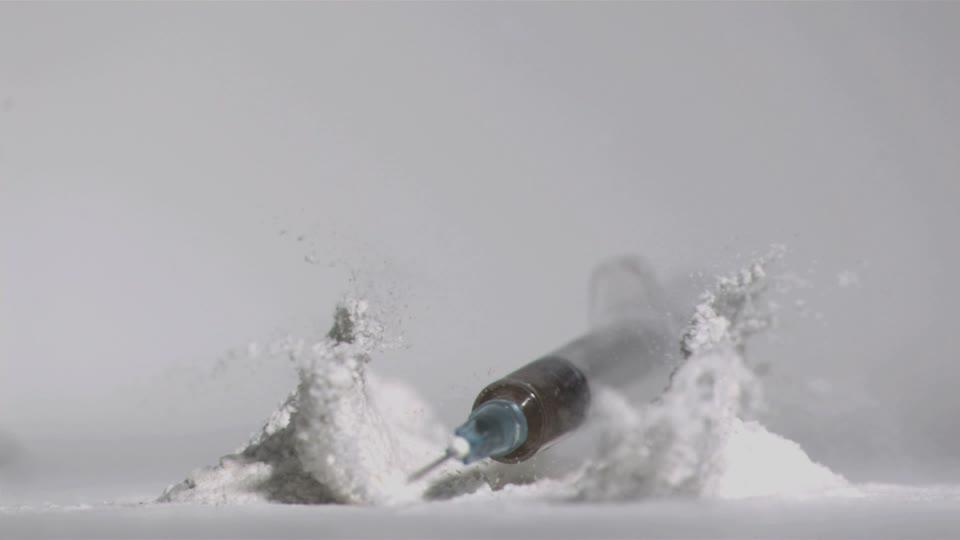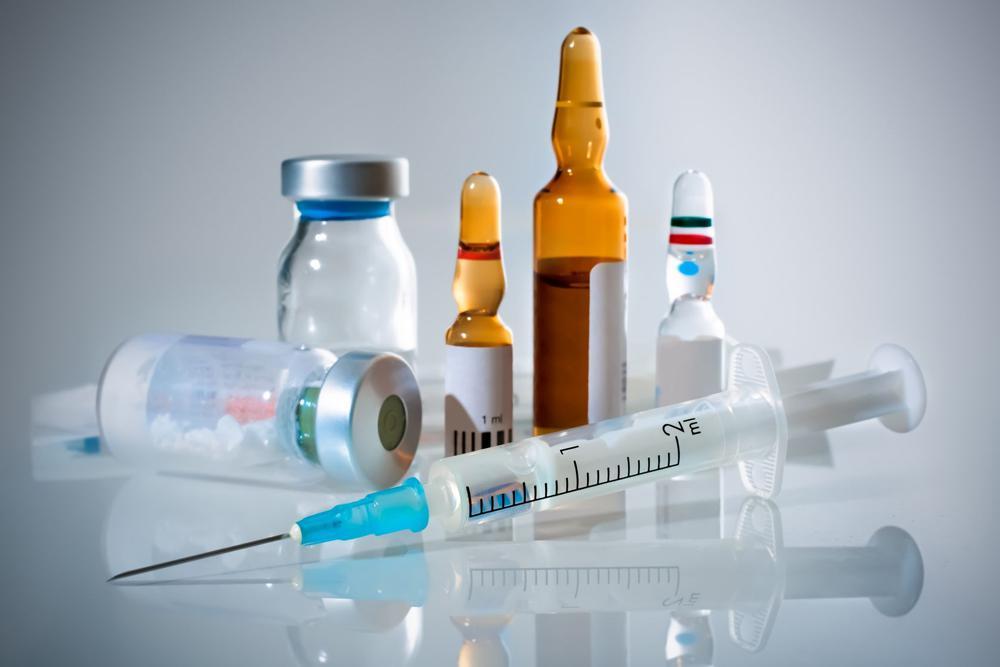The first image is the image on the left, the second image is the image on the right. Considering the images on both sides, is "There are two needles and one spoon." valid? Answer yes or no. No. The first image is the image on the left, the second image is the image on the right. For the images shown, is this caption "There are two syringes and one spoon." true? Answer yes or no. No. 